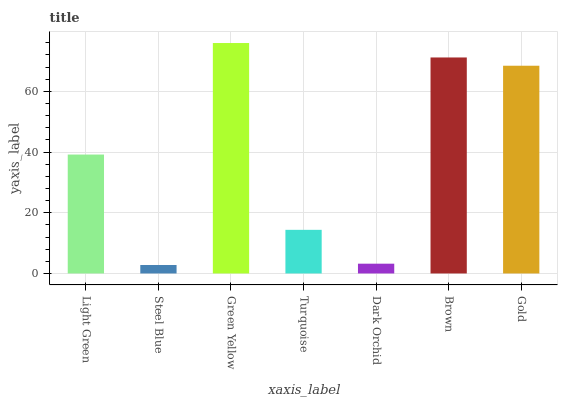Is Green Yellow the minimum?
Answer yes or no. No. Is Steel Blue the maximum?
Answer yes or no. No. Is Green Yellow greater than Steel Blue?
Answer yes or no. Yes. Is Steel Blue less than Green Yellow?
Answer yes or no. Yes. Is Steel Blue greater than Green Yellow?
Answer yes or no. No. Is Green Yellow less than Steel Blue?
Answer yes or no. No. Is Light Green the high median?
Answer yes or no. Yes. Is Light Green the low median?
Answer yes or no. Yes. Is Brown the high median?
Answer yes or no. No. Is Turquoise the low median?
Answer yes or no. No. 